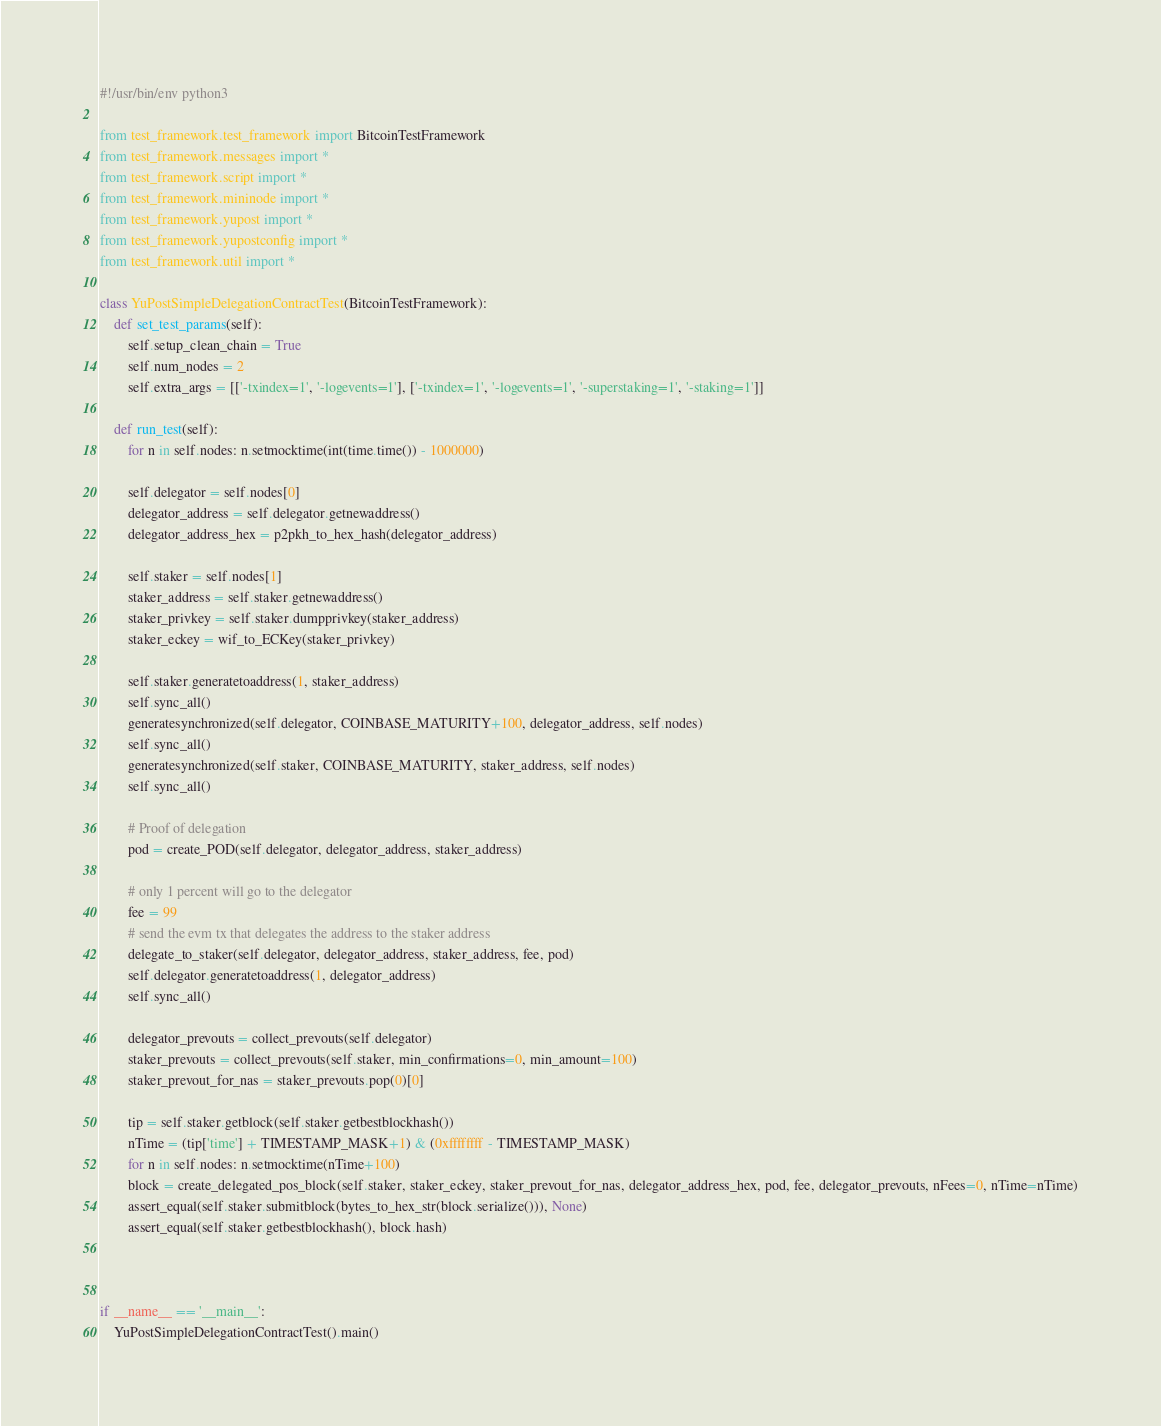<code> <loc_0><loc_0><loc_500><loc_500><_Python_>#!/usr/bin/env python3

from test_framework.test_framework import BitcoinTestFramework
from test_framework.messages import *
from test_framework.script import *
from test_framework.mininode import *
from test_framework.yupost import *
from test_framework.yupostconfig import *
from test_framework.util import *

class YuPostSimpleDelegationContractTest(BitcoinTestFramework):
    def set_test_params(self):
        self.setup_clean_chain = True
        self.num_nodes = 2
        self.extra_args = [['-txindex=1', '-logevents=1'], ['-txindex=1', '-logevents=1', '-superstaking=1', '-staking=1']]

    def run_test(self):
        for n in self.nodes: n.setmocktime(int(time.time()) - 1000000)

        self.delegator = self.nodes[0]
        delegator_address = self.delegator.getnewaddress()
        delegator_address_hex = p2pkh_to_hex_hash(delegator_address)

        self.staker = self.nodes[1]
        staker_address = self.staker.getnewaddress()
        staker_privkey = self.staker.dumpprivkey(staker_address)
        staker_eckey = wif_to_ECKey(staker_privkey)

        self.staker.generatetoaddress(1, staker_address)
        self.sync_all()
        generatesynchronized(self.delegator, COINBASE_MATURITY+100, delegator_address, self.nodes)
        self.sync_all()
        generatesynchronized(self.staker, COINBASE_MATURITY, staker_address, self.nodes)
        self.sync_all()

        # Proof of delegation
        pod = create_POD(self.delegator, delegator_address, staker_address)
        
        # only 1 percent will go to the delegator
        fee = 99
        # send the evm tx that delegates the address to the staker address
        delegate_to_staker(self.delegator, delegator_address, staker_address, fee, pod)
        self.delegator.generatetoaddress(1, delegator_address)
        self.sync_all()

        delegator_prevouts = collect_prevouts(self.delegator)
        staker_prevouts = collect_prevouts(self.staker, min_confirmations=0, min_amount=100)
        staker_prevout_for_nas = staker_prevouts.pop(0)[0]

        tip = self.staker.getblock(self.staker.getbestblockhash())
        nTime = (tip['time'] + TIMESTAMP_MASK+1) & (0xffffffff - TIMESTAMP_MASK)
        for n in self.nodes: n.setmocktime(nTime+100)
        block = create_delegated_pos_block(self.staker, staker_eckey, staker_prevout_for_nas, delegator_address_hex, pod, fee, delegator_prevouts, nFees=0, nTime=nTime)
        assert_equal(self.staker.submitblock(bytes_to_hex_str(block.serialize())), None)
        assert_equal(self.staker.getbestblockhash(), block.hash)



if __name__ == '__main__':
    YuPostSimpleDelegationContractTest().main()
</code> 